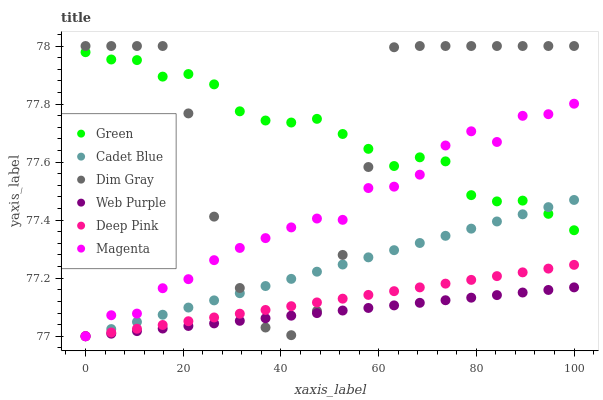Does Web Purple have the minimum area under the curve?
Answer yes or no. Yes. Does Dim Gray have the maximum area under the curve?
Answer yes or no. Yes. Does Deep Pink have the minimum area under the curve?
Answer yes or no. No. Does Deep Pink have the maximum area under the curve?
Answer yes or no. No. Is Deep Pink the smoothest?
Answer yes or no. Yes. Is Dim Gray the roughest?
Answer yes or no. Yes. Is Web Purple the smoothest?
Answer yes or no. No. Is Web Purple the roughest?
Answer yes or no. No. Does Deep Pink have the lowest value?
Answer yes or no. Yes. Does Green have the lowest value?
Answer yes or no. No. Does Dim Gray have the highest value?
Answer yes or no. Yes. Does Deep Pink have the highest value?
Answer yes or no. No. Is Web Purple less than Green?
Answer yes or no. Yes. Is Green greater than Web Purple?
Answer yes or no. Yes. Does Cadet Blue intersect Web Purple?
Answer yes or no. Yes. Is Cadet Blue less than Web Purple?
Answer yes or no. No. Is Cadet Blue greater than Web Purple?
Answer yes or no. No. Does Web Purple intersect Green?
Answer yes or no. No. 